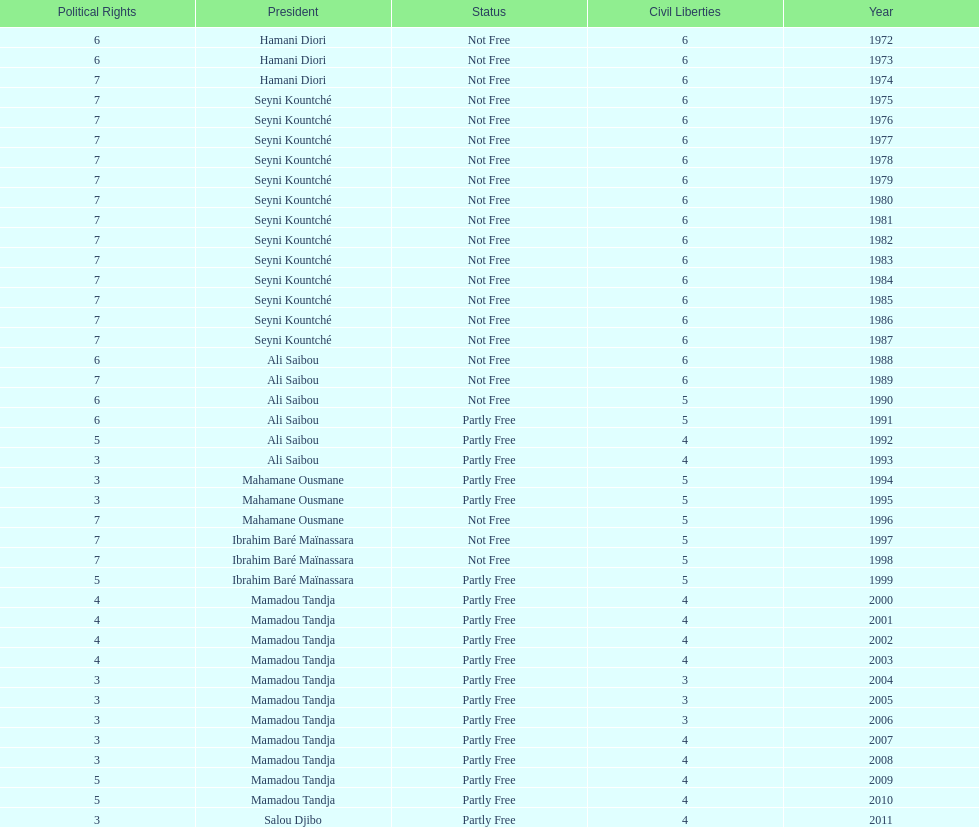How long did it take for civil liberties to decrease below 6? 18 years. 